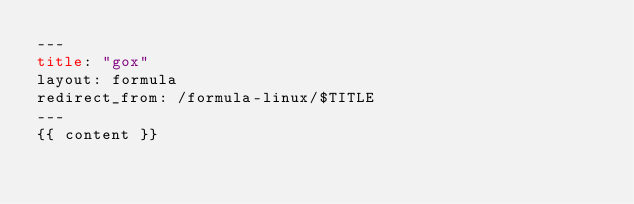<code> <loc_0><loc_0><loc_500><loc_500><_HTML_>---
title: "gox"
layout: formula
redirect_from: /formula-linux/$TITLE
---
{{ content }}
</code> 